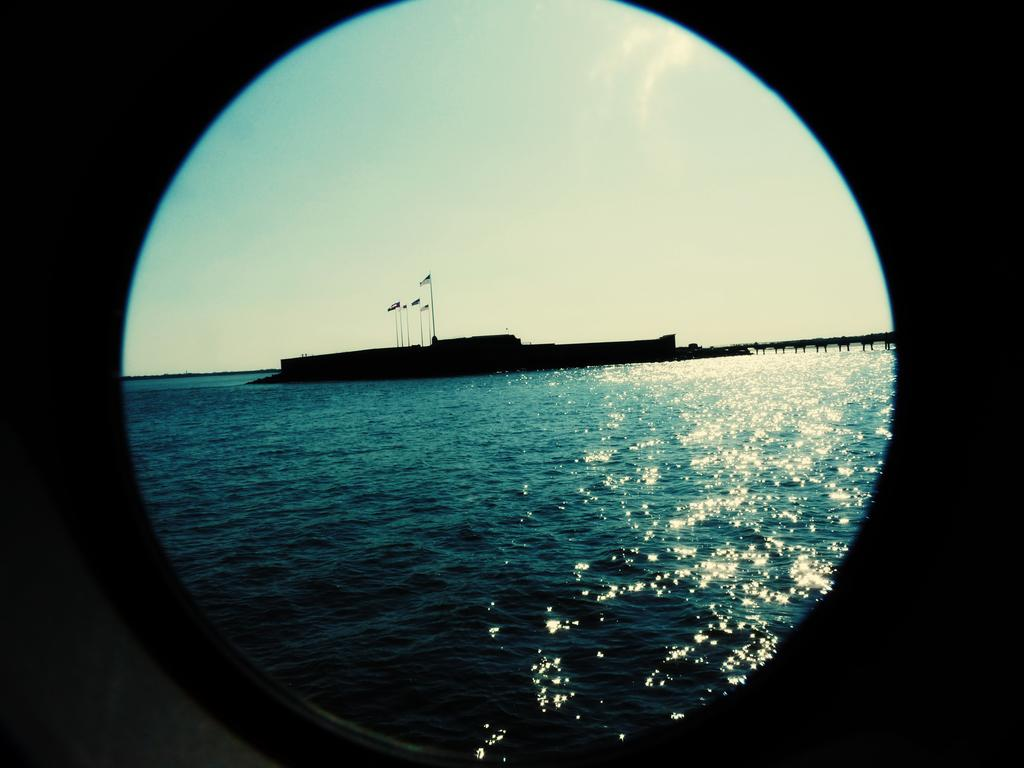What can be seen through the window in the image? Water is visible through the window in the image. What is present in the water? There is a black color object in the water. What is visible in the background of the image? The sky is visible in the background of the image. Who is the owner of the tooth in the image? There is no tooth present in the image, so it is not possible to determine the owner. 